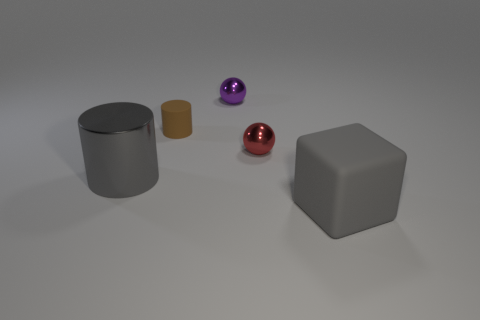Add 5 blue metallic objects. How many objects exist? 10 Subtract all cylinders. How many objects are left? 3 Subtract 0 blue cubes. How many objects are left? 5 Subtract all purple shiny things. Subtract all purple things. How many objects are left? 3 Add 3 big gray rubber blocks. How many big gray rubber blocks are left? 4 Add 5 tiny red metal spheres. How many tiny red metal spheres exist? 6 